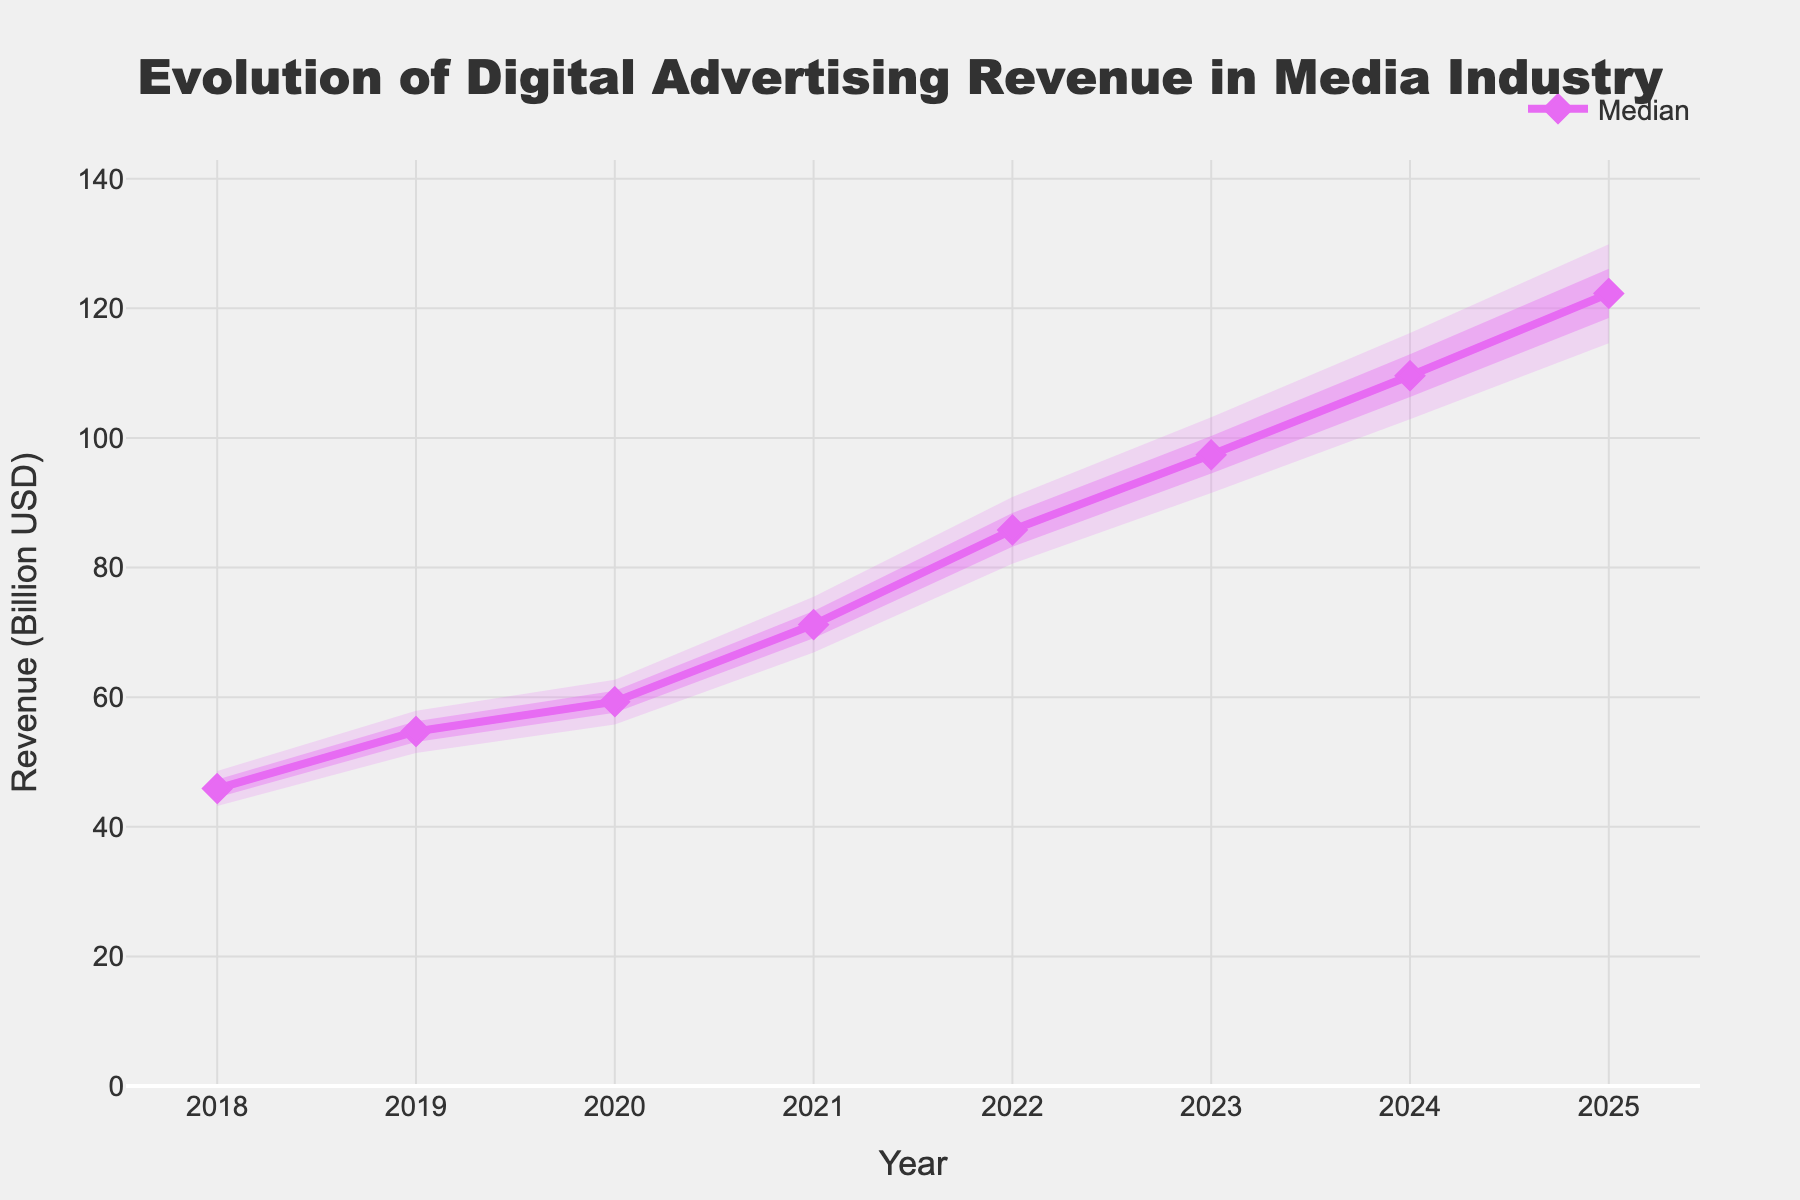What's the title of the plot? The title is displayed prominently at the top center of the plot.
Answer: Evolution of Digital Advertising Revenue in Media Industry What does the y-axis represent? The y-axis title is provided on the vertical axis of the plot.
Answer: Revenue (Billion USD) In which year does the median digital advertising revenue exceed 100 billion USD? The median line crosses the 100 billion USD mark in the year 2024.
Answer: 2024 What is the median digital advertising revenue in 2021? Look at the median line for the year 2021.
Answer: 71.2 billion USD Which year shows the highest uncertainty range in the 90% confidence interval? The 90% confidence interval's width is assessed by the gap between the upper 90% and lower 10% bands; the widest year displays the highest uncertainty.
Answer: 2025 How does the median revenue change from 2018 to 2025? Subtract the 2018 median revenue from the 2025 median revenue to observe the change.
Answer: 76.4 billion USD What is the lower boundary of the 50% confidence interval in 2020? Look at the lower 25% boundary for the year 2020 in the plot.
Answer: 57.6 billion USD Which year shows the highest median digital advertising revenue? Identify the year where the median line is at its highest point on the plot.
Answer: 2025 